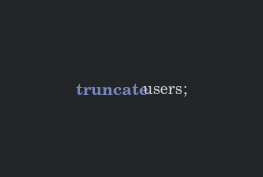Convert code to text. <code><loc_0><loc_0><loc_500><loc_500><_SQL_>truncate users;</code> 